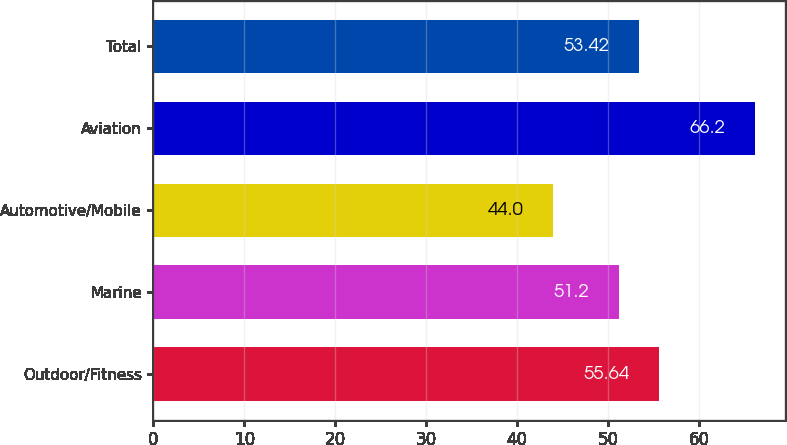<chart> <loc_0><loc_0><loc_500><loc_500><bar_chart><fcel>Outdoor/Fitness<fcel>Marine<fcel>Automotive/Mobile<fcel>Aviation<fcel>Total<nl><fcel>55.64<fcel>51.2<fcel>44<fcel>66.2<fcel>53.42<nl></chart> 